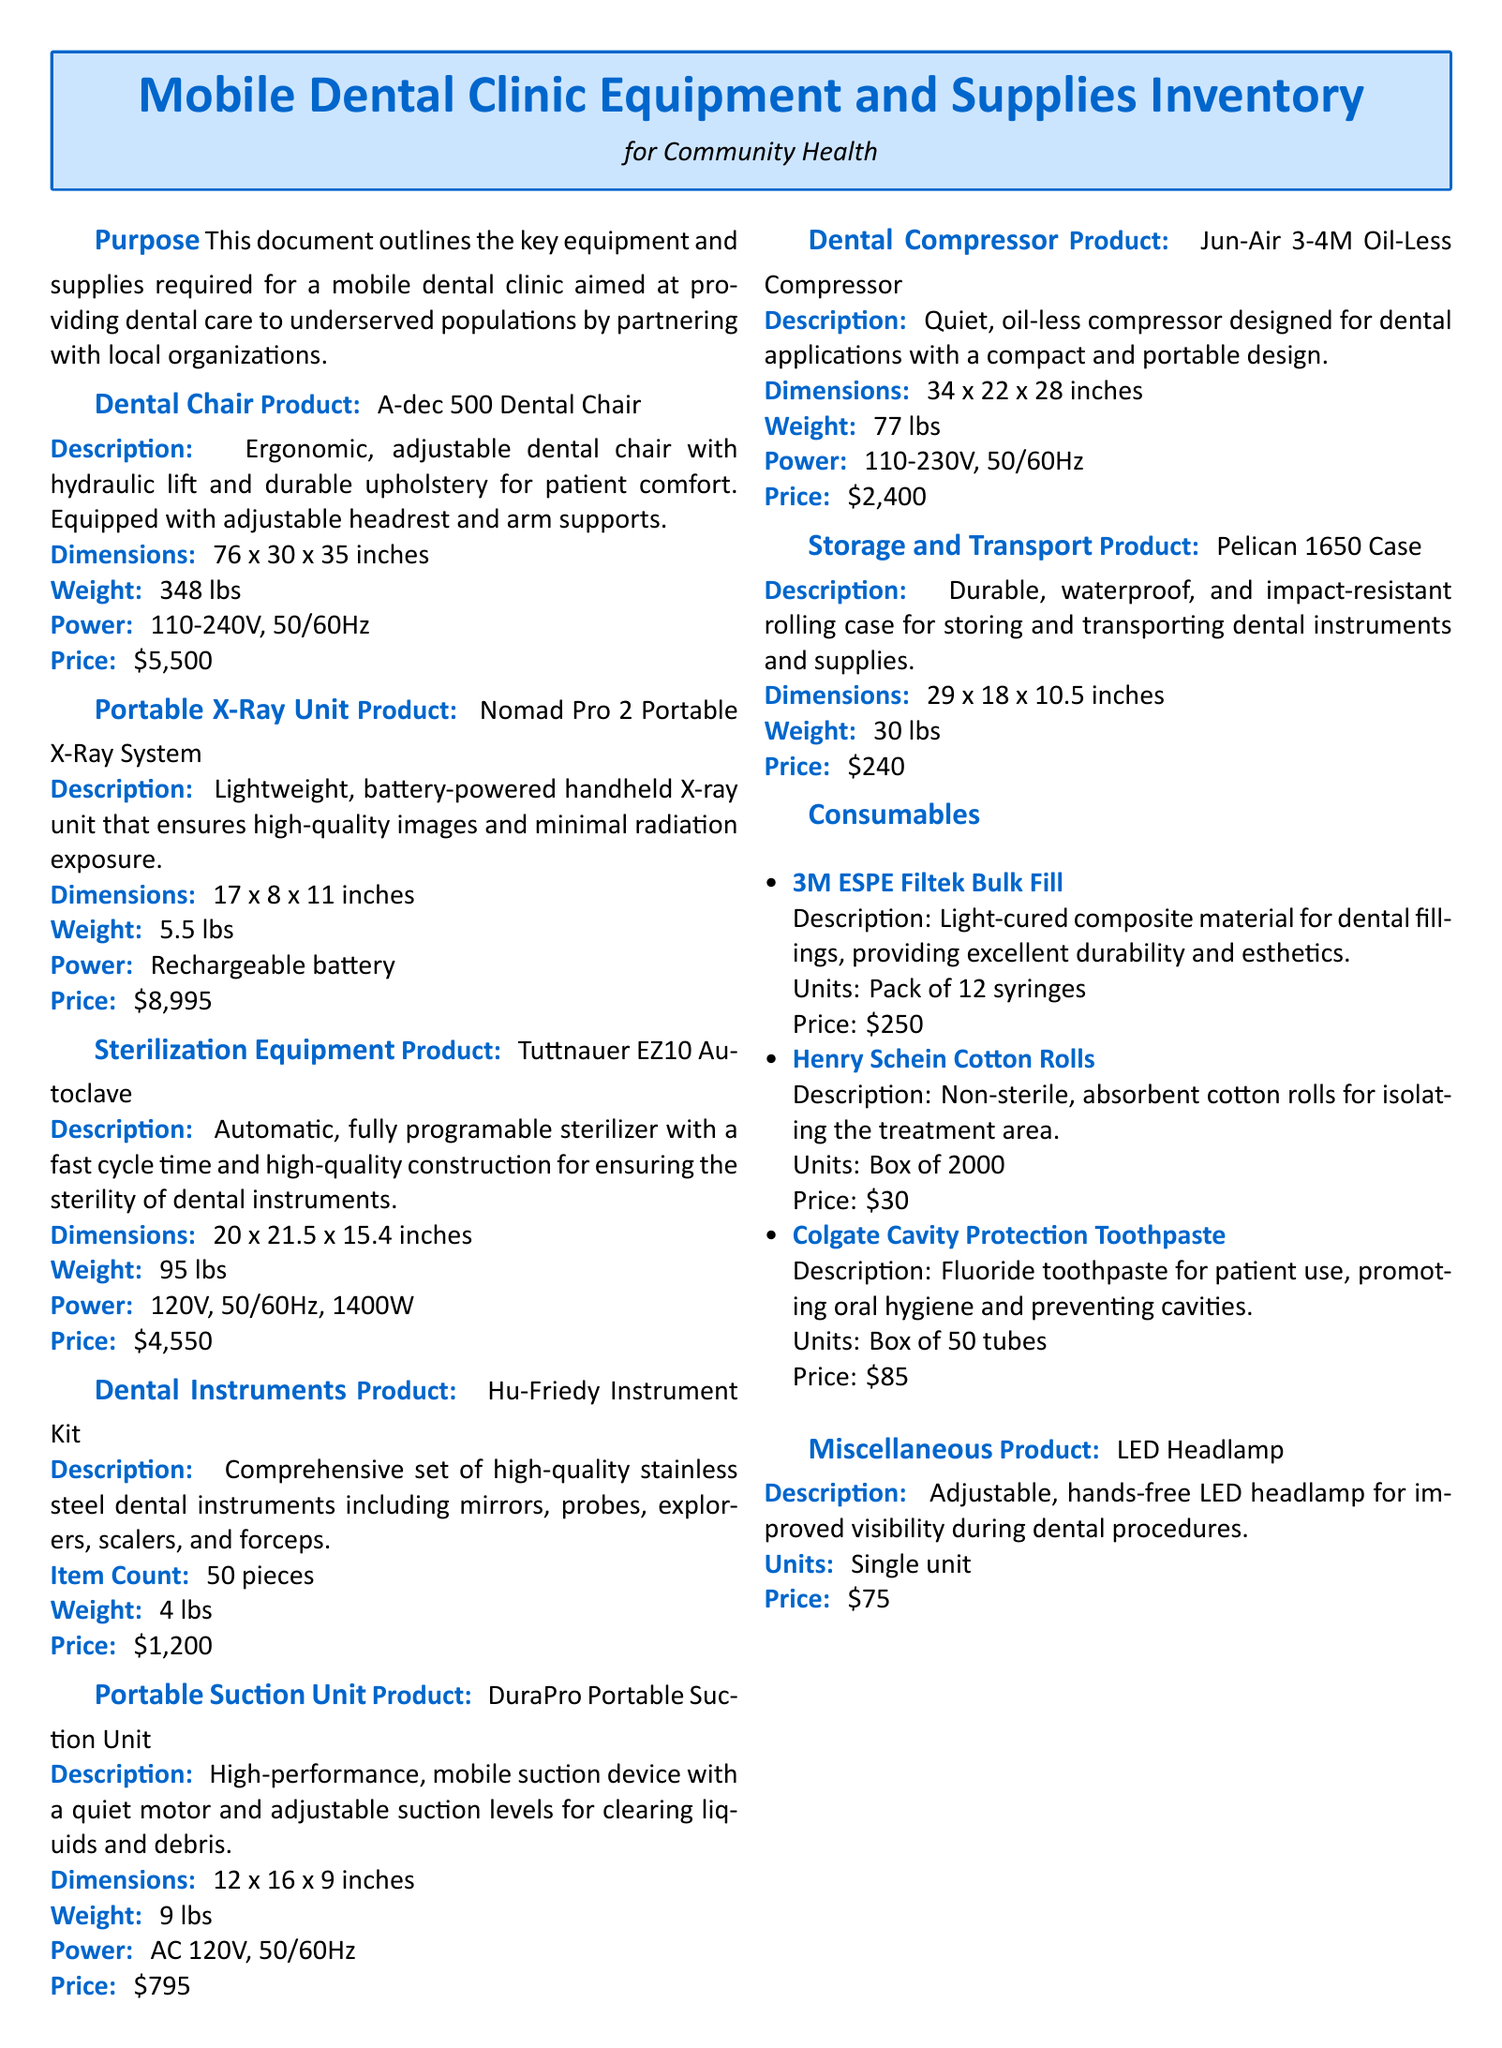What is the product name of the dental chair? The document lists the dental chair as the "A-dec 500 Dental Chair."
Answer: A-dec 500 Dental Chair What is the weight of the Portable X-Ray Unit? The weight of the Nomad Pro 2 Portable X-Ray System is given as 5.5 lbs.
Answer: 5.5 lbs What is the price of the Sterilization Equipment? The Tuttnauer EZ10 Autoclave is priced at $4,550.
Answer: $4,550 How many pieces are in the Hu-Friedy Instrument Kit? The total item count for the Hu-Friedy Instrument Kit is specified as 50 pieces.
Answer: 50 pieces What is the power requirement for the Dental Compressor? The power requirement for the Jun-Air 3-4M Oil-Less Compressor is 110-230V, 50/60Hz.
Answer: 110-230V, 50/60Hz What type of case is used for storage and transport? The document specifies the product as a "Pelican 1650 Case."
Answer: Pelican 1650 Case How many syringes come in a pack of 3M ESPE Filtek Bulk Fill? The document states that a pack contains 12 syringes.
Answer: Pack of 12 syringes What is the description of the LED Headlamp? The LED Headlamp is described as "Adjustable, hands-free LED headlamp for improved visibility during dental procedures."
Answer: Adjustable, hands-free LED headlamp for improved visibility during dental procedures What is the purpose of this document? The purpose stated is to outline the key equipment and supplies for a mobile dental clinic aimed at providing dental care to underserved populations.
Answer: To outline the key equipment and supplies for a mobile dental clinic aimed at providing dental care to underserved populations What is the main focus of the mobile dental clinic? The main focus is on providing dental care to underserved populations by partnering with local organizations.
Answer: Providing dental care to underserved populations 